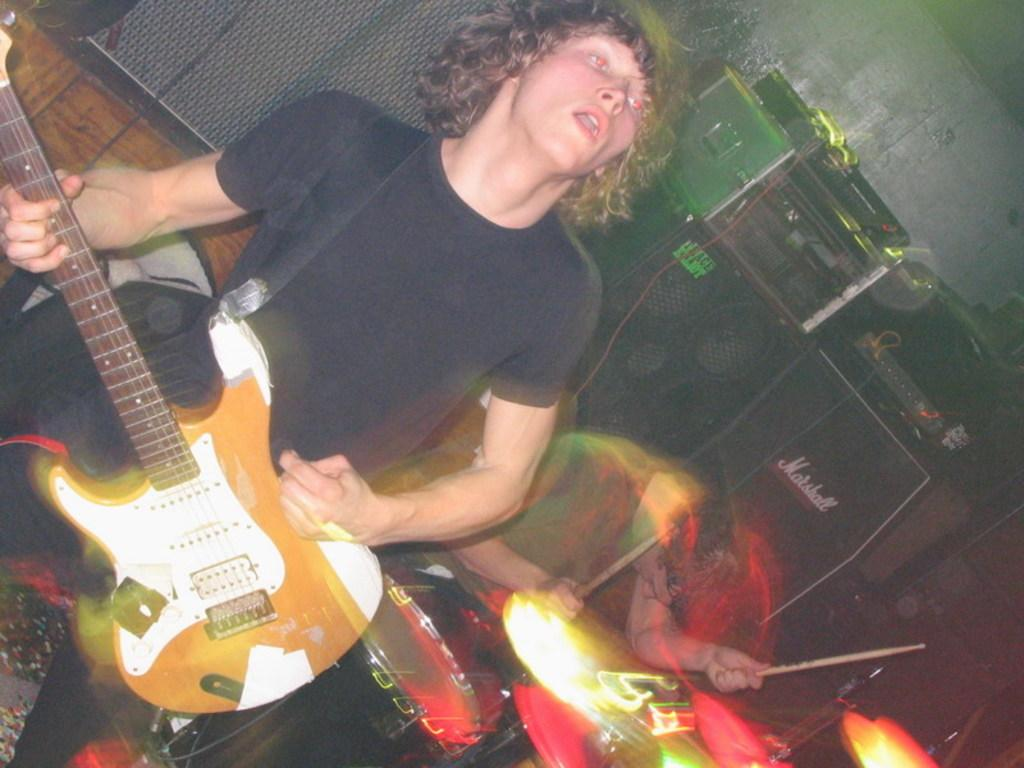What is the man in the image doing? The man is playing a guitar in the image. What other musical instrument can be seen in the image? There are drums in the image. What can be seen in the background of the image? There are musical instruments and a wall visible in the background. What type of machine is being used to play the guitar in the image? There is no machine involved in playing the guitar in the image; it is being played by the man. How many beans are present on the guitar in the image? There are no beans present on the guitar or anywhere else in the image. 